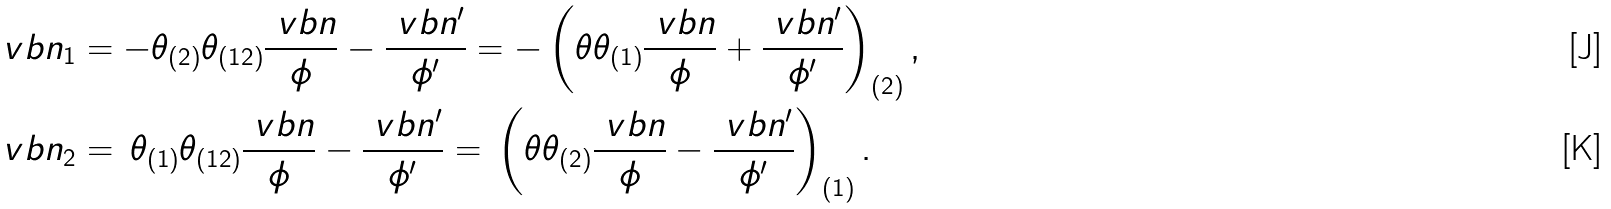<formula> <loc_0><loc_0><loc_500><loc_500>\ v b n _ { 1 } & = - \theta _ { ( 2 ) } \theta _ { ( 1 2 ) } \frac { \ v b n } { \phi } - \frac { \ v b n ^ { \prime } } { \phi ^ { \prime } } = - \left ( \theta \theta _ { ( 1 ) } \frac { \ v b n } { \phi } + \frac { \ v b n ^ { \prime } } { \phi ^ { \prime } } \right ) _ { ( 2 ) } , \\ \ v b n _ { 2 } & = \, \theta _ { ( 1 ) } \theta _ { ( 1 2 ) } \frac { \ v b n } { \phi } - \frac { \ v b n ^ { \prime } } { \phi ^ { \prime } } = \, \left ( \theta \theta _ { ( 2 ) } \frac { \ v b n } { \phi } - \frac { \ v b n ^ { \prime } } { \phi ^ { \prime } } \right ) _ { ( 1 ) } .</formula> 